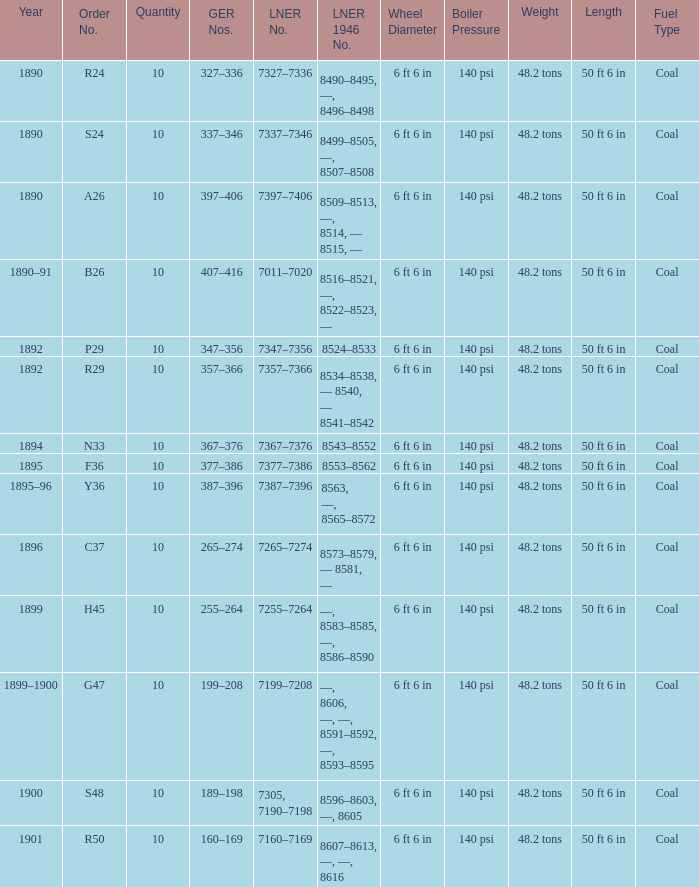Which LNER 1946 number is from 1892 and has an LNER number of 7347–7356? 8524–8533. 